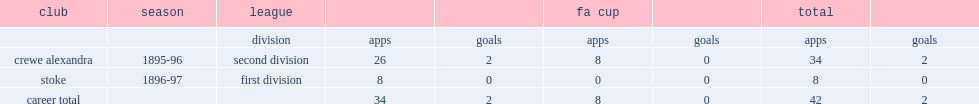During the 1896-97 season, which club in the first division and did harry simpson join and play eight matches for? Stoke. 